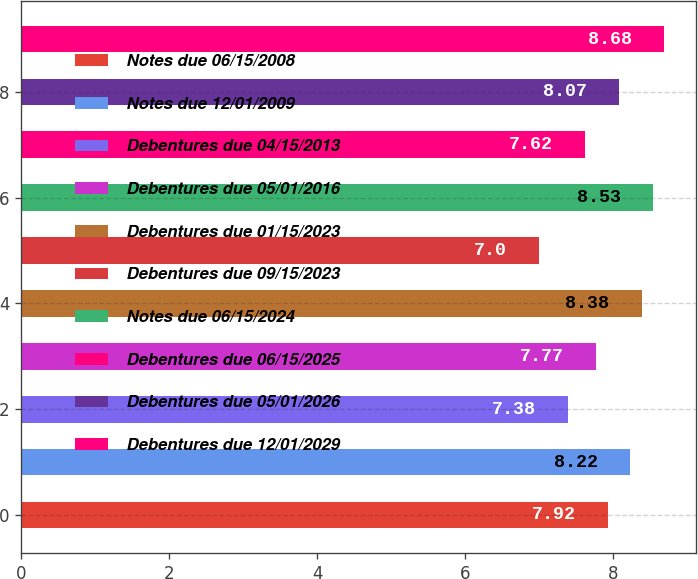Convert chart. <chart><loc_0><loc_0><loc_500><loc_500><bar_chart><fcel>Notes due 06/15/2008<fcel>Notes due 12/01/2009<fcel>Debentures due 04/15/2013<fcel>Debentures due 05/01/2016<fcel>Debentures due 01/15/2023<fcel>Debentures due 09/15/2023<fcel>Notes due 06/15/2024<fcel>Debentures due 06/15/2025<fcel>Debentures due 05/01/2026<fcel>Debentures due 12/01/2029<nl><fcel>7.92<fcel>8.22<fcel>7.38<fcel>7.77<fcel>8.38<fcel>7<fcel>8.53<fcel>7.62<fcel>8.07<fcel>8.68<nl></chart> 